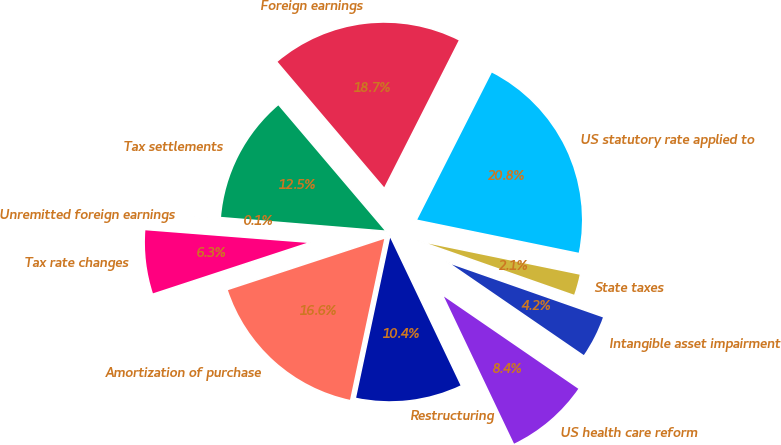<chart> <loc_0><loc_0><loc_500><loc_500><pie_chart><fcel>US statutory rate applied to<fcel>Foreign earnings<fcel>Tax settlements<fcel>Unremitted foreign earnings<fcel>Tax rate changes<fcel>Amortization of purchase<fcel>Restructuring<fcel>US health care reform<fcel>Intangible asset impairment<fcel>State taxes<nl><fcel>20.75%<fcel>18.68%<fcel>12.48%<fcel>0.07%<fcel>6.28%<fcel>16.62%<fcel>10.41%<fcel>8.35%<fcel>4.21%<fcel>2.14%<nl></chart> 